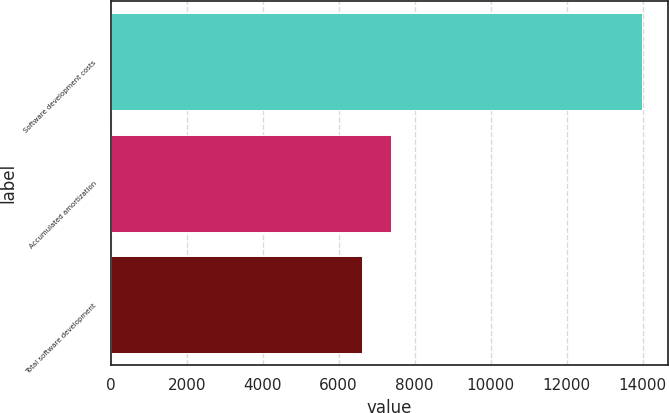<chart> <loc_0><loc_0><loc_500><loc_500><bar_chart><fcel>Software development costs<fcel>Accumulated amortization<fcel>Total software development<nl><fcel>13977<fcel>7367<fcel>6610<nl></chart> 